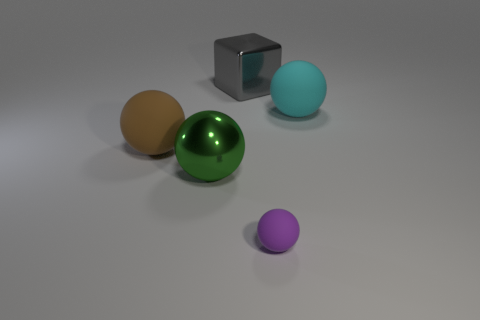What material is the big brown sphere?
Offer a very short reply. Rubber. There is another big object that is the same material as the big brown object; what color is it?
Offer a terse response. Cyan. Are there any big green spheres that are on the right side of the big matte thing that is to the right of the large gray metallic thing?
Make the answer very short. No. What number of other objects are there of the same shape as the green object?
Keep it short and to the point. 3. Does the large matte object right of the small purple sphere have the same shape as the big metallic object behind the large cyan sphere?
Your answer should be compact. No. There is a large rubber sphere that is on the left side of the big metal object behind the big cyan rubber object; how many big balls are behind it?
Your response must be concise. 1. The small rubber thing has what color?
Keep it short and to the point. Purple. How many other objects are there of the same size as the purple ball?
Provide a short and direct response. 0. There is a big brown thing that is the same shape as the big cyan rubber object; what is its material?
Provide a short and direct response. Rubber. There is a big sphere right of the large metallic object that is behind the large matte sphere to the left of the cyan matte sphere; what is its material?
Ensure brevity in your answer.  Rubber. 